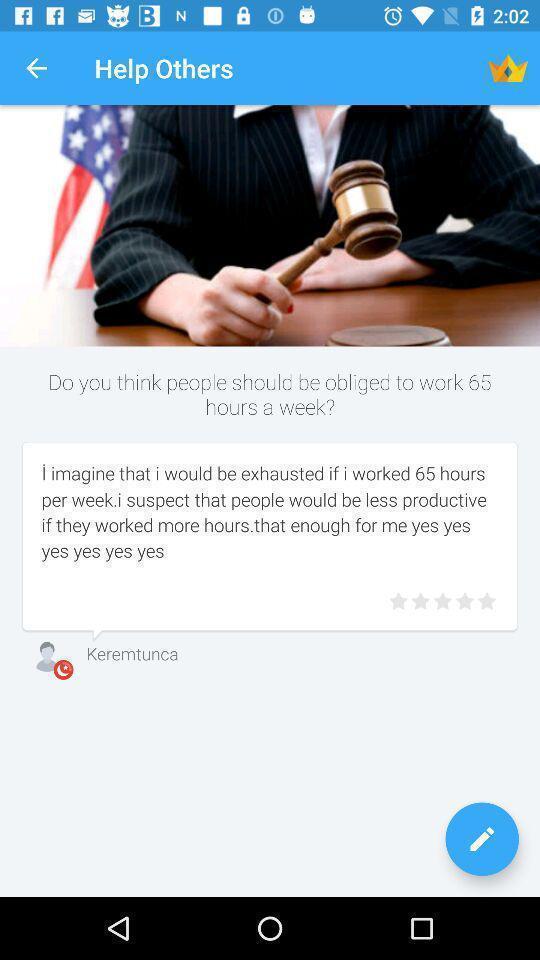What details can you identify in this image? Page displaying information about social application. 